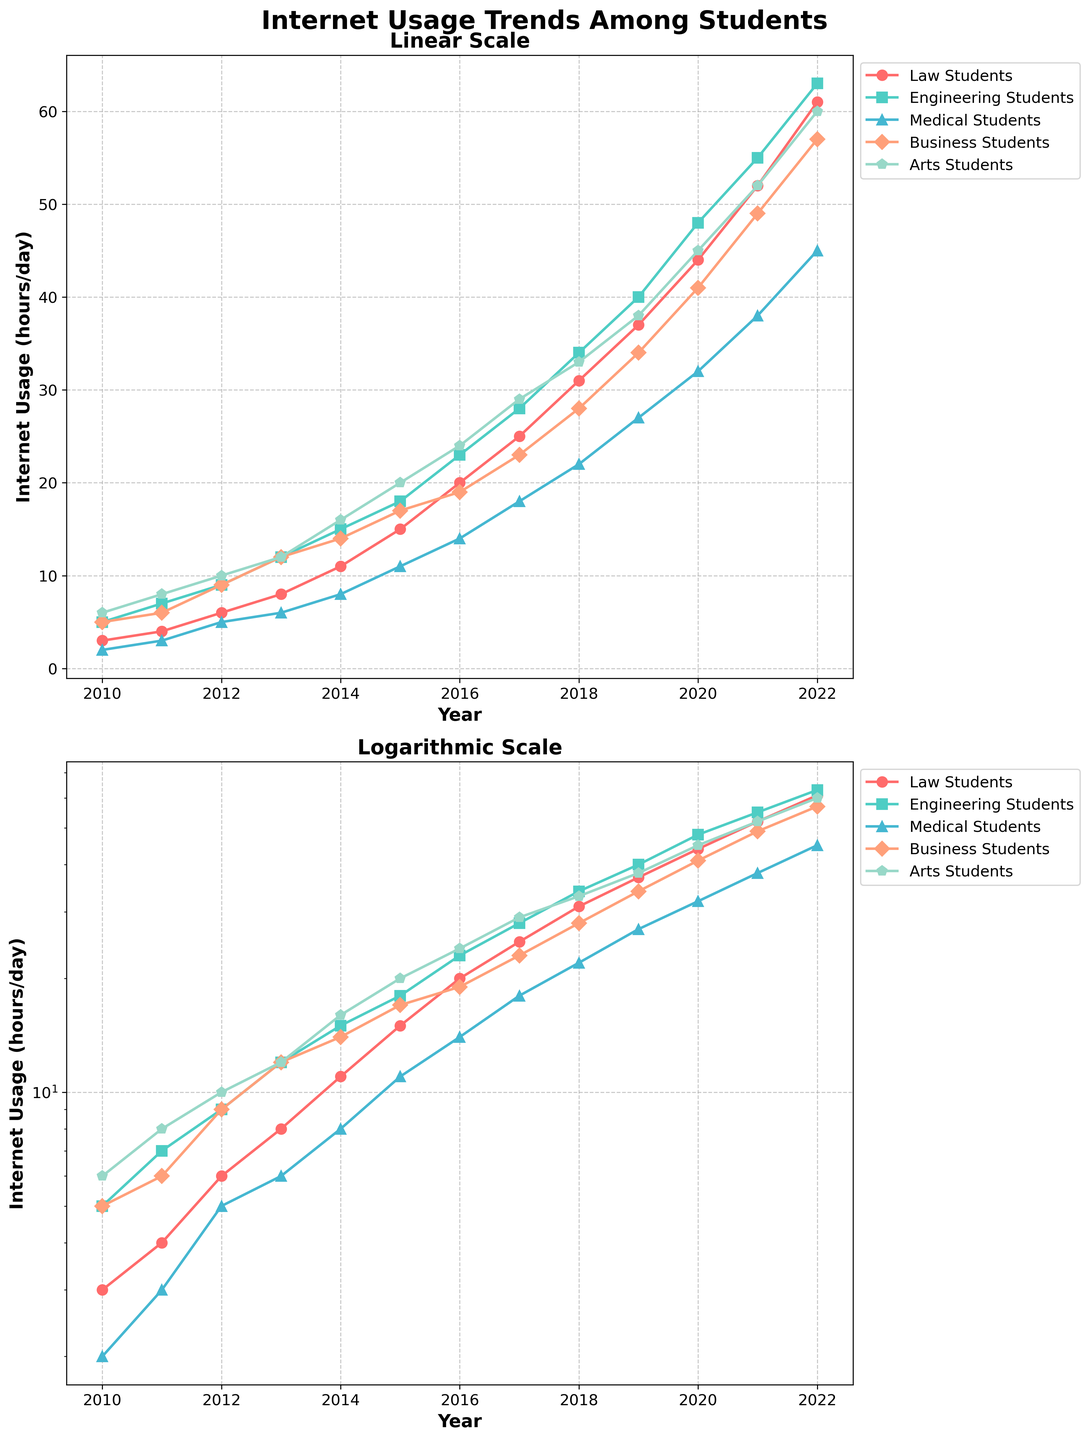What is the title of the figure? The title is written at the top of the figure in bold, large font.
Answer: Internet Usage Trends Among Students Which student group had the highest internet usage in 2022? The highest internet usage in 2022 can be identified from the plot in both linear and logarithmic scales. The Arts Students group shows the highest value.
Answer: Arts Students How many hours per day were Law Students using the internet in 2016? Find the year 2016 on the x-axis, then look at the plotted point for the Law Students group. The y-axis in both scales indicates 20 hours/day.
Answer: 20 What is the general trend in internet usage for Engineering Students from 2010 to 2022? Observing the points for Engineering Students across the years in both subplots, the trend shows that internet usage consistently increases over time.
Answer: Increasing By how many hours did internet usage for Medical Students increase from 2010 to 2022? From the plot, for Medical Students, compare the usage in 2010 (2 hours/day) and in 2022 (45 hours/day). The difference is 45 - 2 = 43 hours/day.
Answer: 43 Which year shows the crossover point where Business Students' internet usage surpassed Medical Students' usage? Locate the intersection point on the plot where the Business Students' line crosses above the Medical Students' line. This happens between 2014 and 2015.
Answer: 2015 If we look at the log scale subplot, what does this tell us about the growth rate of internet usage across the student groups? Logarithmic scales help in observing growth rates; all student groups show an exponential growth pattern, indicating a consistent percentage increase over time.
Answer: Exponential growth On average, how many hours per day did Arts Students use the internet between 2010 and 2022? Calculate the average by summing internet usage for Arts Students from 2010 to 2022 and dividing by the number of years: (6+8+10+12+16+20+24+29+33+38+45+52+60)/13 = 30.38 hours/day.
Answer: 30.38 Compared to Law Students, how much more did Engineering Students use the internet in 2019? In 2019, Law Students used the internet for 37 hours/day, and Engineering Students for 40 hours/day. The difference is 40 - 37 = 3 hours/day.
Answer: 3 In the linear scale subplot, which year shows the most significant increase for Business Students' internet usage? The most significant increase is identified by the steepest slope in Business Students' line, occurring between 2017 and 2018.
Answer: 2018 